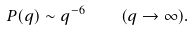<formula> <loc_0><loc_0><loc_500><loc_500>P ( q ) \sim q ^ { - 6 } \quad ( q \rightarrow \infty ) .</formula> 